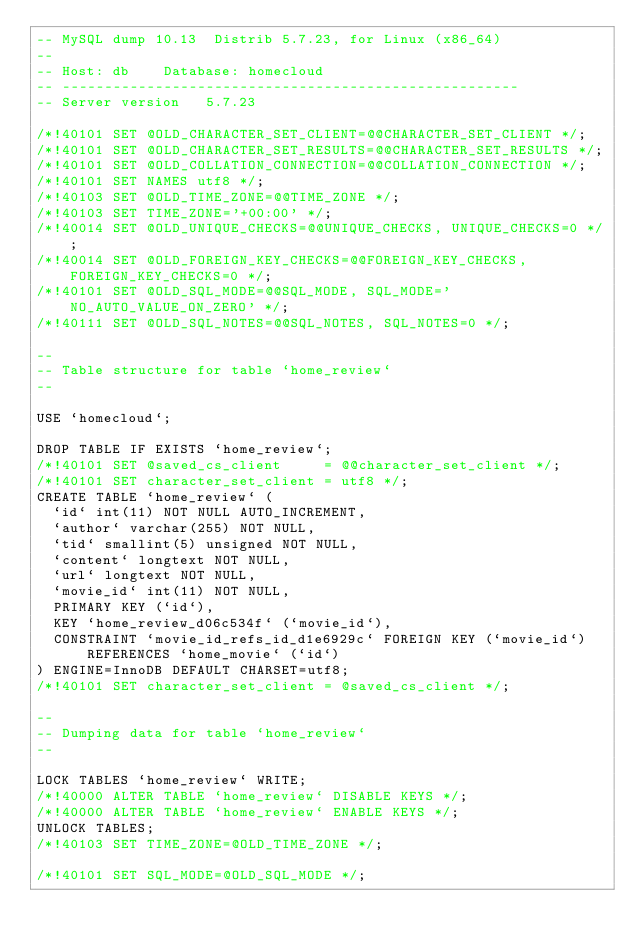Convert code to text. <code><loc_0><loc_0><loc_500><loc_500><_SQL_>-- MySQL dump 10.13  Distrib 5.7.23, for Linux (x86_64)
--
-- Host: db    Database: homecloud
-- ------------------------------------------------------
-- Server version	5.7.23

/*!40101 SET @OLD_CHARACTER_SET_CLIENT=@@CHARACTER_SET_CLIENT */;
/*!40101 SET @OLD_CHARACTER_SET_RESULTS=@@CHARACTER_SET_RESULTS */;
/*!40101 SET @OLD_COLLATION_CONNECTION=@@COLLATION_CONNECTION */;
/*!40101 SET NAMES utf8 */;
/*!40103 SET @OLD_TIME_ZONE=@@TIME_ZONE */;
/*!40103 SET TIME_ZONE='+00:00' */;
/*!40014 SET @OLD_UNIQUE_CHECKS=@@UNIQUE_CHECKS, UNIQUE_CHECKS=0 */;
/*!40014 SET @OLD_FOREIGN_KEY_CHECKS=@@FOREIGN_KEY_CHECKS, FOREIGN_KEY_CHECKS=0 */;
/*!40101 SET @OLD_SQL_MODE=@@SQL_MODE, SQL_MODE='NO_AUTO_VALUE_ON_ZERO' */;
/*!40111 SET @OLD_SQL_NOTES=@@SQL_NOTES, SQL_NOTES=0 */;

--
-- Table structure for table `home_review`
--

USE `homecloud`; 

DROP TABLE IF EXISTS `home_review`;
/*!40101 SET @saved_cs_client     = @@character_set_client */;
/*!40101 SET character_set_client = utf8 */;
CREATE TABLE `home_review` (
  `id` int(11) NOT NULL AUTO_INCREMENT,
  `author` varchar(255) NOT NULL,
  `tid` smallint(5) unsigned NOT NULL,
  `content` longtext NOT NULL,
  `url` longtext NOT NULL,
  `movie_id` int(11) NOT NULL,
  PRIMARY KEY (`id`),
  KEY `home_review_d06c534f` (`movie_id`),
  CONSTRAINT `movie_id_refs_id_d1e6929c` FOREIGN KEY (`movie_id`) REFERENCES `home_movie` (`id`)
) ENGINE=InnoDB DEFAULT CHARSET=utf8;
/*!40101 SET character_set_client = @saved_cs_client */;

--
-- Dumping data for table `home_review`
--

LOCK TABLES `home_review` WRITE;
/*!40000 ALTER TABLE `home_review` DISABLE KEYS */;
/*!40000 ALTER TABLE `home_review` ENABLE KEYS */;
UNLOCK TABLES;
/*!40103 SET TIME_ZONE=@OLD_TIME_ZONE */;

/*!40101 SET SQL_MODE=@OLD_SQL_MODE */;</code> 